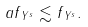<formula> <loc_0><loc_0><loc_500><loc_500>\| a f \| _ { Y ^ { s } } \lesssim \| f \| _ { Y ^ { s } } .</formula> 